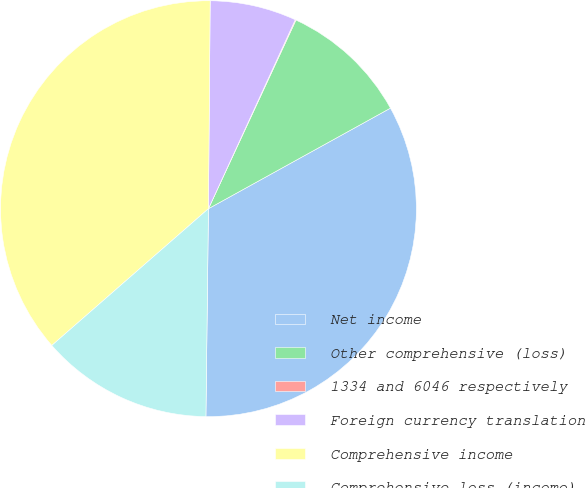Convert chart to OTSL. <chart><loc_0><loc_0><loc_500><loc_500><pie_chart><fcel>Net income<fcel>Other comprehensive (loss)<fcel>1334 and 6046 respectively<fcel>Foreign currency translation<fcel>Comprehensive income<fcel>Comprehensive loss (income)<nl><fcel>33.22%<fcel>10.05%<fcel>0.06%<fcel>6.72%<fcel>36.55%<fcel>13.38%<nl></chart> 